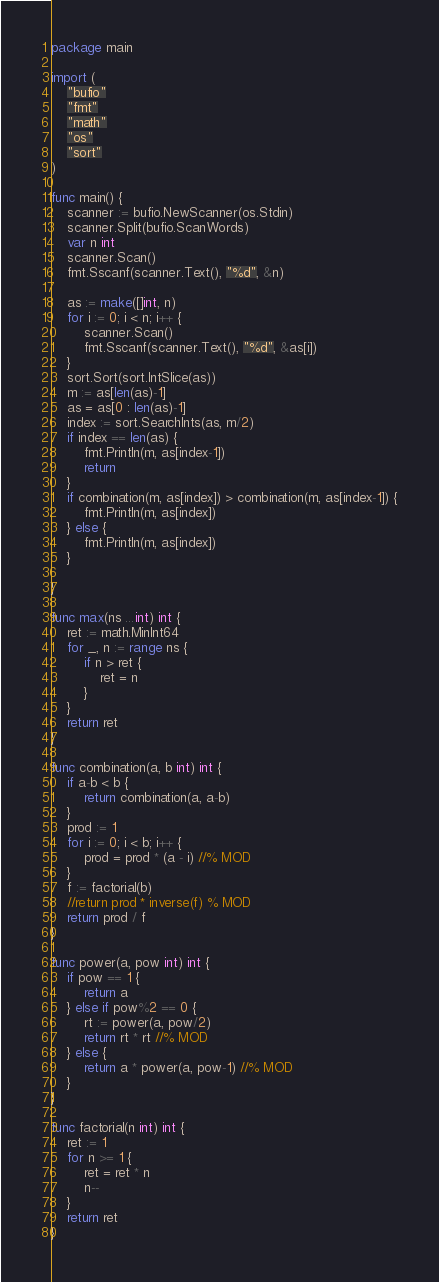<code> <loc_0><loc_0><loc_500><loc_500><_Go_>package main

import (
	"bufio"
	"fmt"
	"math"
	"os"
	"sort"
)

func main() {
	scanner := bufio.NewScanner(os.Stdin)
	scanner.Split(bufio.ScanWords)
	var n int
	scanner.Scan()
	fmt.Sscanf(scanner.Text(), "%d", &n)

	as := make([]int, n)
	for i := 0; i < n; i++ {
		scanner.Scan()
		fmt.Sscanf(scanner.Text(), "%d", &as[i])
	}
	sort.Sort(sort.IntSlice(as))
	m := as[len(as)-1]
	as = as[0 : len(as)-1]
	index := sort.SearchInts(as, m/2)
	if index == len(as) {
		fmt.Println(m, as[index-1])
		return
	}
	if combination(m, as[index]) > combination(m, as[index-1]) {
		fmt.Println(m, as[index])
	} else {
		fmt.Println(m, as[index])
	}

}

func max(ns ...int) int {
	ret := math.MinInt64
	for _, n := range ns {
		if n > ret {
			ret = n
		}
	}
	return ret
}

func combination(a, b int) int {
	if a-b < b {
		return combination(a, a-b)
	}
	prod := 1
	for i := 0; i < b; i++ {
		prod = prod * (a - i) //% MOD
	}
	f := factorial(b)
	//return prod * inverse(f) % MOD
	return prod / f
}

func power(a, pow int) int {
	if pow == 1 {
		return a
	} else if pow%2 == 0 {
		rt := power(a, pow/2)
		return rt * rt //% MOD
	} else {
		return a * power(a, pow-1) //% MOD
	}
}

func factorial(n int) int {
	ret := 1
	for n >= 1 {
		ret = ret * n
		n--
	}
	return ret
}
</code> 